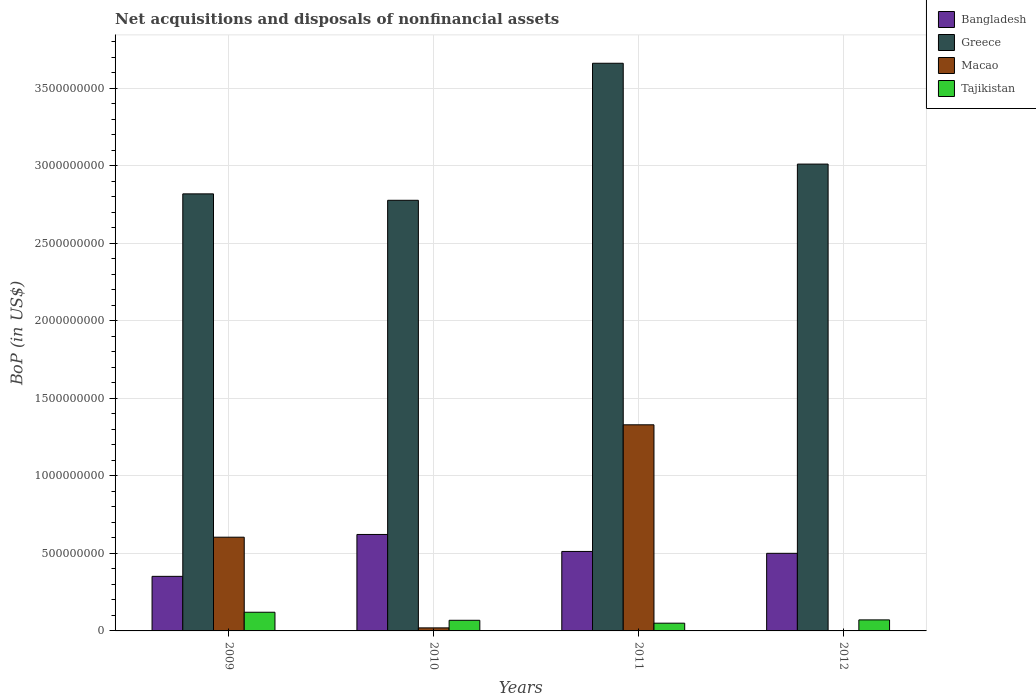How many bars are there on the 2nd tick from the left?
Make the answer very short. 4. How many bars are there on the 3rd tick from the right?
Provide a succinct answer. 4. What is the label of the 1st group of bars from the left?
Your response must be concise. 2009. What is the Balance of Payments in Bangladesh in 2011?
Your answer should be compact. 5.12e+08. Across all years, what is the maximum Balance of Payments in Tajikistan?
Your response must be concise. 1.20e+08. Across all years, what is the minimum Balance of Payments in Greece?
Provide a short and direct response. 2.78e+09. In which year was the Balance of Payments in Greece maximum?
Provide a succinct answer. 2011. What is the total Balance of Payments in Greece in the graph?
Your answer should be compact. 1.23e+1. What is the difference between the Balance of Payments in Tajikistan in 2011 and that in 2012?
Your response must be concise. -2.12e+07. What is the difference between the Balance of Payments in Tajikistan in 2010 and the Balance of Payments in Greece in 2012?
Your answer should be very brief. -2.94e+09. What is the average Balance of Payments in Tajikistan per year?
Offer a very short reply. 7.75e+07. In the year 2010, what is the difference between the Balance of Payments in Bangladesh and Balance of Payments in Greece?
Provide a succinct answer. -2.15e+09. In how many years, is the Balance of Payments in Bangladesh greater than 1500000000 US$?
Your answer should be compact. 0. What is the ratio of the Balance of Payments in Tajikistan in 2009 to that in 2012?
Give a very brief answer. 1.69. What is the difference between the highest and the second highest Balance of Payments in Bangladesh?
Provide a succinct answer. 1.09e+08. What is the difference between the highest and the lowest Balance of Payments in Tajikistan?
Make the answer very short. 7.05e+07. Is the sum of the Balance of Payments in Greece in 2011 and 2012 greater than the maximum Balance of Payments in Bangladesh across all years?
Offer a terse response. Yes. Is it the case that in every year, the sum of the Balance of Payments in Tajikistan and Balance of Payments in Greece is greater than the sum of Balance of Payments in Macao and Balance of Payments in Bangladesh?
Offer a very short reply. No. Are all the bars in the graph horizontal?
Your answer should be compact. No. How many years are there in the graph?
Give a very brief answer. 4. Does the graph contain grids?
Your answer should be compact. Yes. Where does the legend appear in the graph?
Give a very brief answer. Top right. How many legend labels are there?
Provide a short and direct response. 4. What is the title of the graph?
Offer a terse response. Net acquisitions and disposals of nonfinancial assets. What is the label or title of the X-axis?
Provide a short and direct response. Years. What is the label or title of the Y-axis?
Offer a very short reply. BoP (in US$). What is the BoP (in US$) in Bangladesh in 2009?
Your answer should be very brief. 3.52e+08. What is the BoP (in US$) of Greece in 2009?
Your answer should be very brief. 2.82e+09. What is the BoP (in US$) in Macao in 2009?
Your answer should be compact. 6.04e+08. What is the BoP (in US$) in Tajikistan in 2009?
Offer a very short reply. 1.20e+08. What is the BoP (in US$) of Bangladesh in 2010?
Make the answer very short. 6.22e+08. What is the BoP (in US$) of Greece in 2010?
Your answer should be very brief. 2.78e+09. What is the BoP (in US$) in Macao in 2010?
Provide a short and direct response. 1.96e+07. What is the BoP (in US$) in Tajikistan in 2010?
Give a very brief answer. 6.85e+07. What is the BoP (in US$) of Bangladesh in 2011?
Ensure brevity in your answer.  5.12e+08. What is the BoP (in US$) of Greece in 2011?
Provide a short and direct response. 3.66e+09. What is the BoP (in US$) of Macao in 2011?
Your answer should be compact. 1.33e+09. What is the BoP (in US$) in Tajikistan in 2011?
Your answer should be compact. 4.99e+07. What is the BoP (in US$) in Bangladesh in 2012?
Offer a terse response. 5.00e+08. What is the BoP (in US$) of Greece in 2012?
Ensure brevity in your answer.  3.01e+09. What is the BoP (in US$) in Macao in 2012?
Offer a terse response. 0. What is the BoP (in US$) in Tajikistan in 2012?
Offer a very short reply. 7.11e+07. Across all years, what is the maximum BoP (in US$) of Bangladesh?
Your answer should be compact. 6.22e+08. Across all years, what is the maximum BoP (in US$) of Greece?
Your answer should be compact. 3.66e+09. Across all years, what is the maximum BoP (in US$) of Macao?
Ensure brevity in your answer.  1.33e+09. Across all years, what is the maximum BoP (in US$) in Tajikistan?
Make the answer very short. 1.20e+08. Across all years, what is the minimum BoP (in US$) in Bangladesh?
Offer a terse response. 3.52e+08. Across all years, what is the minimum BoP (in US$) in Greece?
Keep it short and to the point. 2.78e+09. Across all years, what is the minimum BoP (in US$) of Tajikistan?
Keep it short and to the point. 4.99e+07. What is the total BoP (in US$) in Bangladesh in the graph?
Provide a short and direct response. 1.99e+09. What is the total BoP (in US$) of Greece in the graph?
Your response must be concise. 1.23e+1. What is the total BoP (in US$) in Macao in the graph?
Your response must be concise. 1.95e+09. What is the total BoP (in US$) in Tajikistan in the graph?
Make the answer very short. 3.10e+08. What is the difference between the BoP (in US$) in Bangladesh in 2009 and that in 2010?
Ensure brevity in your answer.  -2.70e+08. What is the difference between the BoP (in US$) of Greece in 2009 and that in 2010?
Offer a terse response. 4.14e+07. What is the difference between the BoP (in US$) in Macao in 2009 and that in 2010?
Ensure brevity in your answer.  5.85e+08. What is the difference between the BoP (in US$) in Tajikistan in 2009 and that in 2010?
Provide a short and direct response. 5.19e+07. What is the difference between the BoP (in US$) of Bangladesh in 2009 and that in 2011?
Give a very brief answer. -1.61e+08. What is the difference between the BoP (in US$) in Greece in 2009 and that in 2011?
Offer a very short reply. -8.42e+08. What is the difference between the BoP (in US$) of Macao in 2009 and that in 2011?
Your answer should be very brief. -7.25e+08. What is the difference between the BoP (in US$) in Tajikistan in 2009 and that in 2011?
Provide a succinct answer. 7.05e+07. What is the difference between the BoP (in US$) in Bangladesh in 2009 and that in 2012?
Provide a succinct answer. -1.48e+08. What is the difference between the BoP (in US$) of Greece in 2009 and that in 2012?
Your answer should be compact. -1.92e+08. What is the difference between the BoP (in US$) of Tajikistan in 2009 and that in 2012?
Keep it short and to the point. 4.93e+07. What is the difference between the BoP (in US$) of Bangladesh in 2010 and that in 2011?
Offer a terse response. 1.09e+08. What is the difference between the BoP (in US$) in Greece in 2010 and that in 2011?
Provide a short and direct response. -8.83e+08. What is the difference between the BoP (in US$) in Macao in 2010 and that in 2011?
Offer a terse response. -1.31e+09. What is the difference between the BoP (in US$) in Tajikistan in 2010 and that in 2011?
Keep it short and to the point. 1.86e+07. What is the difference between the BoP (in US$) of Bangladesh in 2010 and that in 2012?
Ensure brevity in your answer.  1.22e+08. What is the difference between the BoP (in US$) of Greece in 2010 and that in 2012?
Offer a very short reply. -2.33e+08. What is the difference between the BoP (in US$) in Tajikistan in 2010 and that in 2012?
Provide a succinct answer. -2.58e+06. What is the difference between the BoP (in US$) in Bangladesh in 2011 and that in 2012?
Provide a succinct answer. 1.21e+07. What is the difference between the BoP (in US$) of Greece in 2011 and that in 2012?
Your answer should be very brief. 6.50e+08. What is the difference between the BoP (in US$) of Tajikistan in 2011 and that in 2012?
Provide a short and direct response. -2.12e+07. What is the difference between the BoP (in US$) of Bangladesh in 2009 and the BoP (in US$) of Greece in 2010?
Offer a very short reply. -2.42e+09. What is the difference between the BoP (in US$) in Bangladesh in 2009 and the BoP (in US$) in Macao in 2010?
Make the answer very short. 3.32e+08. What is the difference between the BoP (in US$) of Bangladesh in 2009 and the BoP (in US$) of Tajikistan in 2010?
Keep it short and to the point. 2.83e+08. What is the difference between the BoP (in US$) in Greece in 2009 and the BoP (in US$) in Macao in 2010?
Your response must be concise. 2.80e+09. What is the difference between the BoP (in US$) in Greece in 2009 and the BoP (in US$) in Tajikistan in 2010?
Keep it short and to the point. 2.75e+09. What is the difference between the BoP (in US$) of Macao in 2009 and the BoP (in US$) of Tajikistan in 2010?
Give a very brief answer. 5.36e+08. What is the difference between the BoP (in US$) of Bangladesh in 2009 and the BoP (in US$) of Greece in 2011?
Offer a very short reply. -3.31e+09. What is the difference between the BoP (in US$) in Bangladesh in 2009 and the BoP (in US$) in Macao in 2011?
Offer a very short reply. -9.77e+08. What is the difference between the BoP (in US$) of Bangladesh in 2009 and the BoP (in US$) of Tajikistan in 2011?
Ensure brevity in your answer.  3.02e+08. What is the difference between the BoP (in US$) in Greece in 2009 and the BoP (in US$) in Macao in 2011?
Your answer should be compact. 1.49e+09. What is the difference between the BoP (in US$) of Greece in 2009 and the BoP (in US$) of Tajikistan in 2011?
Offer a terse response. 2.77e+09. What is the difference between the BoP (in US$) of Macao in 2009 and the BoP (in US$) of Tajikistan in 2011?
Your response must be concise. 5.54e+08. What is the difference between the BoP (in US$) in Bangladesh in 2009 and the BoP (in US$) in Greece in 2012?
Keep it short and to the point. -2.66e+09. What is the difference between the BoP (in US$) of Bangladesh in 2009 and the BoP (in US$) of Tajikistan in 2012?
Your answer should be very brief. 2.81e+08. What is the difference between the BoP (in US$) in Greece in 2009 and the BoP (in US$) in Tajikistan in 2012?
Your response must be concise. 2.75e+09. What is the difference between the BoP (in US$) in Macao in 2009 and the BoP (in US$) in Tajikistan in 2012?
Offer a terse response. 5.33e+08. What is the difference between the BoP (in US$) in Bangladesh in 2010 and the BoP (in US$) in Greece in 2011?
Offer a terse response. -3.04e+09. What is the difference between the BoP (in US$) of Bangladesh in 2010 and the BoP (in US$) of Macao in 2011?
Offer a very short reply. -7.07e+08. What is the difference between the BoP (in US$) in Bangladesh in 2010 and the BoP (in US$) in Tajikistan in 2011?
Keep it short and to the point. 5.72e+08. What is the difference between the BoP (in US$) in Greece in 2010 and the BoP (in US$) in Macao in 2011?
Your response must be concise. 1.45e+09. What is the difference between the BoP (in US$) in Greece in 2010 and the BoP (in US$) in Tajikistan in 2011?
Offer a terse response. 2.73e+09. What is the difference between the BoP (in US$) of Macao in 2010 and the BoP (in US$) of Tajikistan in 2011?
Your answer should be compact. -3.03e+07. What is the difference between the BoP (in US$) of Bangladesh in 2010 and the BoP (in US$) of Greece in 2012?
Your answer should be very brief. -2.39e+09. What is the difference between the BoP (in US$) in Bangladesh in 2010 and the BoP (in US$) in Tajikistan in 2012?
Your answer should be very brief. 5.51e+08. What is the difference between the BoP (in US$) in Greece in 2010 and the BoP (in US$) in Tajikistan in 2012?
Ensure brevity in your answer.  2.71e+09. What is the difference between the BoP (in US$) in Macao in 2010 and the BoP (in US$) in Tajikistan in 2012?
Your response must be concise. -5.15e+07. What is the difference between the BoP (in US$) in Bangladesh in 2011 and the BoP (in US$) in Greece in 2012?
Your answer should be very brief. -2.50e+09. What is the difference between the BoP (in US$) in Bangladesh in 2011 and the BoP (in US$) in Tajikistan in 2012?
Provide a succinct answer. 4.41e+08. What is the difference between the BoP (in US$) of Greece in 2011 and the BoP (in US$) of Tajikistan in 2012?
Provide a short and direct response. 3.59e+09. What is the difference between the BoP (in US$) of Macao in 2011 and the BoP (in US$) of Tajikistan in 2012?
Provide a short and direct response. 1.26e+09. What is the average BoP (in US$) of Bangladesh per year?
Offer a very short reply. 4.97e+08. What is the average BoP (in US$) in Greece per year?
Provide a short and direct response. 3.07e+09. What is the average BoP (in US$) in Macao per year?
Ensure brevity in your answer.  4.88e+08. What is the average BoP (in US$) of Tajikistan per year?
Your answer should be very brief. 7.75e+07. In the year 2009, what is the difference between the BoP (in US$) in Bangladesh and BoP (in US$) in Greece?
Your answer should be very brief. -2.47e+09. In the year 2009, what is the difference between the BoP (in US$) in Bangladesh and BoP (in US$) in Macao?
Your answer should be compact. -2.52e+08. In the year 2009, what is the difference between the BoP (in US$) of Bangladesh and BoP (in US$) of Tajikistan?
Give a very brief answer. 2.31e+08. In the year 2009, what is the difference between the BoP (in US$) in Greece and BoP (in US$) in Macao?
Offer a terse response. 2.21e+09. In the year 2009, what is the difference between the BoP (in US$) of Greece and BoP (in US$) of Tajikistan?
Your answer should be very brief. 2.70e+09. In the year 2009, what is the difference between the BoP (in US$) in Macao and BoP (in US$) in Tajikistan?
Provide a short and direct response. 4.84e+08. In the year 2010, what is the difference between the BoP (in US$) of Bangladesh and BoP (in US$) of Greece?
Your answer should be very brief. -2.15e+09. In the year 2010, what is the difference between the BoP (in US$) in Bangladesh and BoP (in US$) in Macao?
Provide a short and direct response. 6.02e+08. In the year 2010, what is the difference between the BoP (in US$) of Bangladesh and BoP (in US$) of Tajikistan?
Provide a short and direct response. 5.53e+08. In the year 2010, what is the difference between the BoP (in US$) in Greece and BoP (in US$) in Macao?
Your answer should be very brief. 2.76e+09. In the year 2010, what is the difference between the BoP (in US$) in Greece and BoP (in US$) in Tajikistan?
Offer a terse response. 2.71e+09. In the year 2010, what is the difference between the BoP (in US$) of Macao and BoP (in US$) of Tajikistan?
Give a very brief answer. -4.89e+07. In the year 2011, what is the difference between the BoP (in US$) in Bangladesh and BoP (in US$) in Greece?
Your response must be concise. -3.15e+09. In the year 2011, what is the difference between the BoP (in US$) of Bangladesh and BoP (in US$) of Macao?
Your response must be concise. -8.16e+08. In the year 2011, what is the difference between the BoP (in US$) of Bangladesh and BoP (in US$) of Tajikistan?
Your response must be concise. 4.62e+08. In the year 2011, what is the difference between the BoP (in US$) in Greece and BoP (in US$) in Macao?
Offer a terse response. 2.33e+09. In the year 2011, what is the difference between the BoP (in US$) in Greece and BoP (in US$) in Tajikistan?
Provide a short and direct response. 3.61e+09. In the year 2011, what is the difference between the BoP (in US$) in Macao and BoP (in US$) in Tajikistan?
Make the answer very short. 1.28e+09. In the year 2012, what is the difference between the BoP (in US$) in Bangladesh and BoP (in US$) in Greece?
Your answer should be compact. -2.51e+09. In the year 2012, what is the difference between the BoP (in US$) in Bangladesh and BoP (in US$) in Tajikistan?
Offer a very short reply. 4.29e+08. In the year 2012, what is the difference between the BoP (in US$) of Greece and BoP (in US$) of Tajikistan?
Make the answer very short. 2.94e+09. What is the ratio of the BoP (in US$) in Bangladesh in 2009 to that in 2010?
Your response must be concise. 0.57. What is the ratio of the BoP (in US$) in Greece in 2009 to that in 2010?
Provide a succinct answer. 1.01. What is the ratio of the BoP (in US$) of Macao in 2009 to that in 2010?
Make the answer very short. 30.83. What is the ratio of the BoP (in US$) of Tajikistan in 2009 to that in 2010?
Give a very brief answer. 1.76. What is the ratio of the BoP (in US$) of Bangladesh in 2009 to that in 2011?
Ensure brevity in your answer.  0.69. What is the ratio of the BoP (in US$) of Greece in 2009 to that in 2011?
Offer a terse response. 0.77. What is the ratio of the BoP (in US$) of Macao in 2009 to that in 2011?
Offer a very short reply. 0.45. What is the ratio of the BoP (in US$) in Tajikistan in 2009 to that in 2011?
Provide a succinct answer. 2.41. What is the ratio of the BoP (in US$) in Bangladesh in 2009 to that in 2012?
Ensure brevity in your answer.  0.7. What is the ratio of the BoP (in US$) of Greece in 2009 to that in 2012?
Provide a succinct answer. 0.94. What is the ratio of the BoP (in US$) of Tajikistan in 2009 to that in 2012?
Offer a terse response. 1.69. What is the ratio of the BoP (in US$) of Bangladesh in 2010 to that in 2011?
Your response must be concise. 1.21. What is the ratio of the BoP (in US$) of Greece in 2010 to that in 2011?
Offer a very short reply. 0.76. What is the ratio of the BoP (in US$) of Macao in 2010 to that in 2011?
Your answer should be compact. 0.01. What is the ratio of the BoP (in US$) of Tajikistan in 2010 to that in 2011?
Make the answer very short. 1.37. What is the ratio of the BoP (in US$) in Bangladesh in 2010 to that in 2012?
Keep it short and to the point. 1.24. What is the ratio of the BoP (in US$) of Greece in 2010 to that in 2012?
Your response must be concise. 0.92. What is the ratio of the BoP (in US$) of Tajikistan in 2010 to that in 2012?
Keep it short and to the point. 0.96. What is the ratio of the BoP (in US$) of Bangladesh in 2011 to that in 2012?
Ensure brevity in your answer.  1.02. What is the ratio of the BoP (in US$) of Greece in 2011 to that in 2012?
Provide a short and direct response. 1.22. What is the ratio of the BoP (in US$) in Tajikistan in 2011 to that in 2012?
Your response must be concise. 0.7. What is the difference between the highest and the second highest BoP (in US$) of Bangladesh?
Keep it short and to the point. 1.09e+08. What is the difference between the highest and the second highest BoP (in US$) of Greece?
Ensure brevity in your answer.  6.50e+08. What is the difference between the highest and the second highest BoP (in US$) of Macao?
Your answer should be compact. 7.25e+08. What is the difference between the highest and the second highest BoP (in US$) in Tajikistan?
Keep it short and to the point. 4.93e+07. What is the difference between the highest and the lowest BoP (in US$) of Bangladesh?
Keep it short and to the point. 2.70e+08. What is the difference between the highest and the lowest BoP (in US$) of Greece?
Provide a succinct answer. 8.83e+08. What is the difference between the highest and the lowest BoP (in US$) in Macao?
Ensure brevity in your answer.  1.33e+09. What is the difference between the highest and the lowest BoP (in US$) in Tajikistan?
Your answer should be very brief. 7.05e+07. 